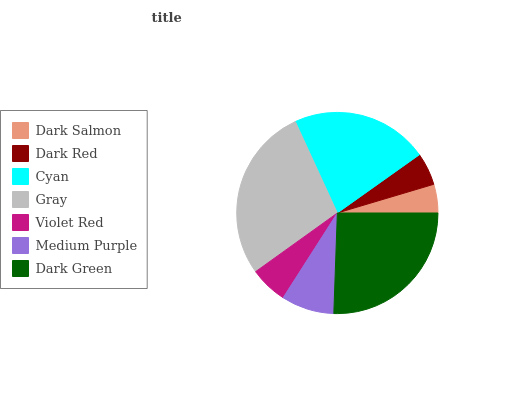Is Dark Salmon the minimum?
Answer yes or no. Yes. Is Gray the maximum?
Answer yes or no. Yes. Is Dark Red the minimum?
Answer yes or no. No. Is Dark Red the maximum?
Answer yes or no. No. Is Dark Red greater than Dark Salmon?
Answer yes or no. Yes. Is Dark Salmon less than Dark Red?
Answer yes or no. Yes. Is Dark Salmon greater than Dark Red?
Answer yes or no. No. Is Dark Red less than Dark Salmon?
Answer yes or no. No. Is Medium Purple the high median?
Answer yes or no. Yes. Is Medium Purple the low median?
Answer yes or no. Yes. Is Cyan the high median?
Answer yes or no. No. Is Cyan the low median?
Answer yes or no. No. 